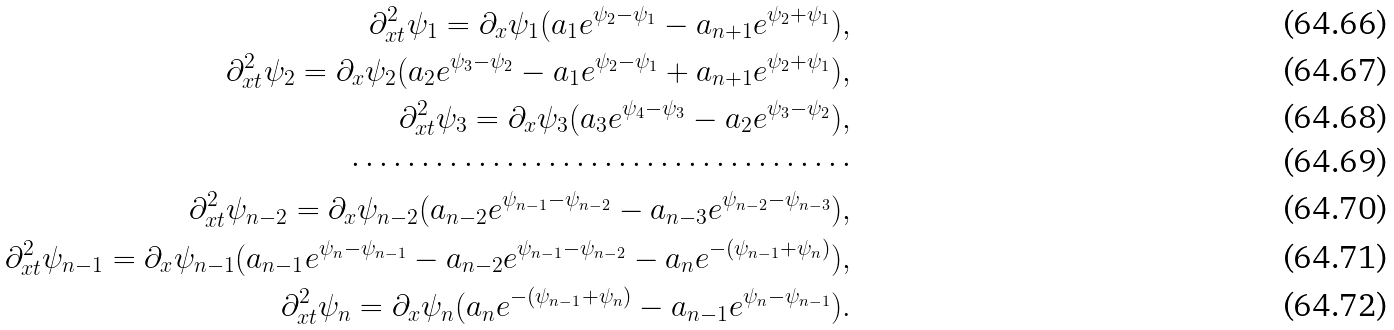Convert formula to latex. <formula><loc_0><loc_0><loc_500><loc_500>\partial ^ { 2 } _ { x t } \psi _ { 1 } = \partial _ { x } \psi _ { 1 } ( a _ { 1 } e ^ { \psi _ { 2 } - \psi _ { 1 } } - a _ { n + 1 } e ^ { \psi _ { 2 } + \psi _ { 1 } } ) , \\ \partial ^ { 2 } _ { x t } \psi _ { 2 } = \partial _ { x } \psi _ { 2 } ( a _ { 2 } e ^ { \psi _ { 3 } - \psi _ { 2 } } - a _ { 1 } e ^ { \psi _ { 2 } - \psi _ { 1 } } + a _ { n + 1 } e ^ { \psi _ { 2 } + \psi _ { 1 } } ) , \\ \partial ^ { 2 } _ { x t } \psi _ { 3 } = \partial _ { x } \psi _ { 3 } ( a _ { 3 } e ^ { \psi _ { 4 } - \psi _ { 3 } } - a _ { 2 } e ^ { \psi _ { 3 } - \psi _ { 2 } } ) , \\ \cdots \cdots \cdots \cdots \cdots \cdots \cdots \cdots \cdots \cdots \cdots \cdots \\ \partial ^ { 2 } _ { x t } \psi _ { n - 2 } = \partial _ { x } \psi _ { n - 2 } ( a _ { n - 2 } e ^ { \psi _ { n - 1 } - \psi _ { n - 2 } } - a _ { n - 3 } e ^ { \psi _ { n - 2 } - \psi _ { n - 3 } } ) , \\ \partial ^ { 2 } _ { x t } \psi _ { n - 1 } = \partial _ { x } \psi _ { n - 1 } ( a _ { n - 1 } e ^ { \psi _ { n } - \psi _ { n - 1 } } - a _ { n - 2 } e ^ { \psi _ { n - 1 } - \psi _ { n - 2 } } - a _ { n } e ^ { - ( \psi _ { n - 1 } + \psi _ { n } ) } ) , \\ \partial ^ { 2 } _ { x t } \psi _ { n } = \partial _ { x } \psi _ { n } ( a _ { n } e ^ { - ( \psi _ { n - 1 } + \psi _ { n } ) } - a _ { n - 1 } e ^ { \psi _ { n } - \psi _ { n - 1 } } ) .</formula> 